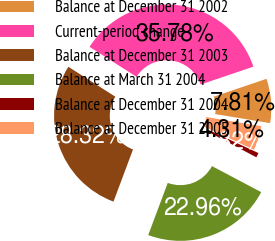Convert chart to OTSL. <chart><loc_0><loc_0><loc_500><loc_500><pie_chart><fcel>Balance at December 31 2002<fcel>Current-period change<fcel>Balance at December 31 2003<fcel>Balance at March 31 2004<fcel>Balance at December 31 2004<fcel>Balance at December 31 2005<nl><fcel>7.81%<fcel>35.78%<fcel>28.32%<fcel>22.96%<fcel>0.82%<fcel>4.31%<nl></chart> 